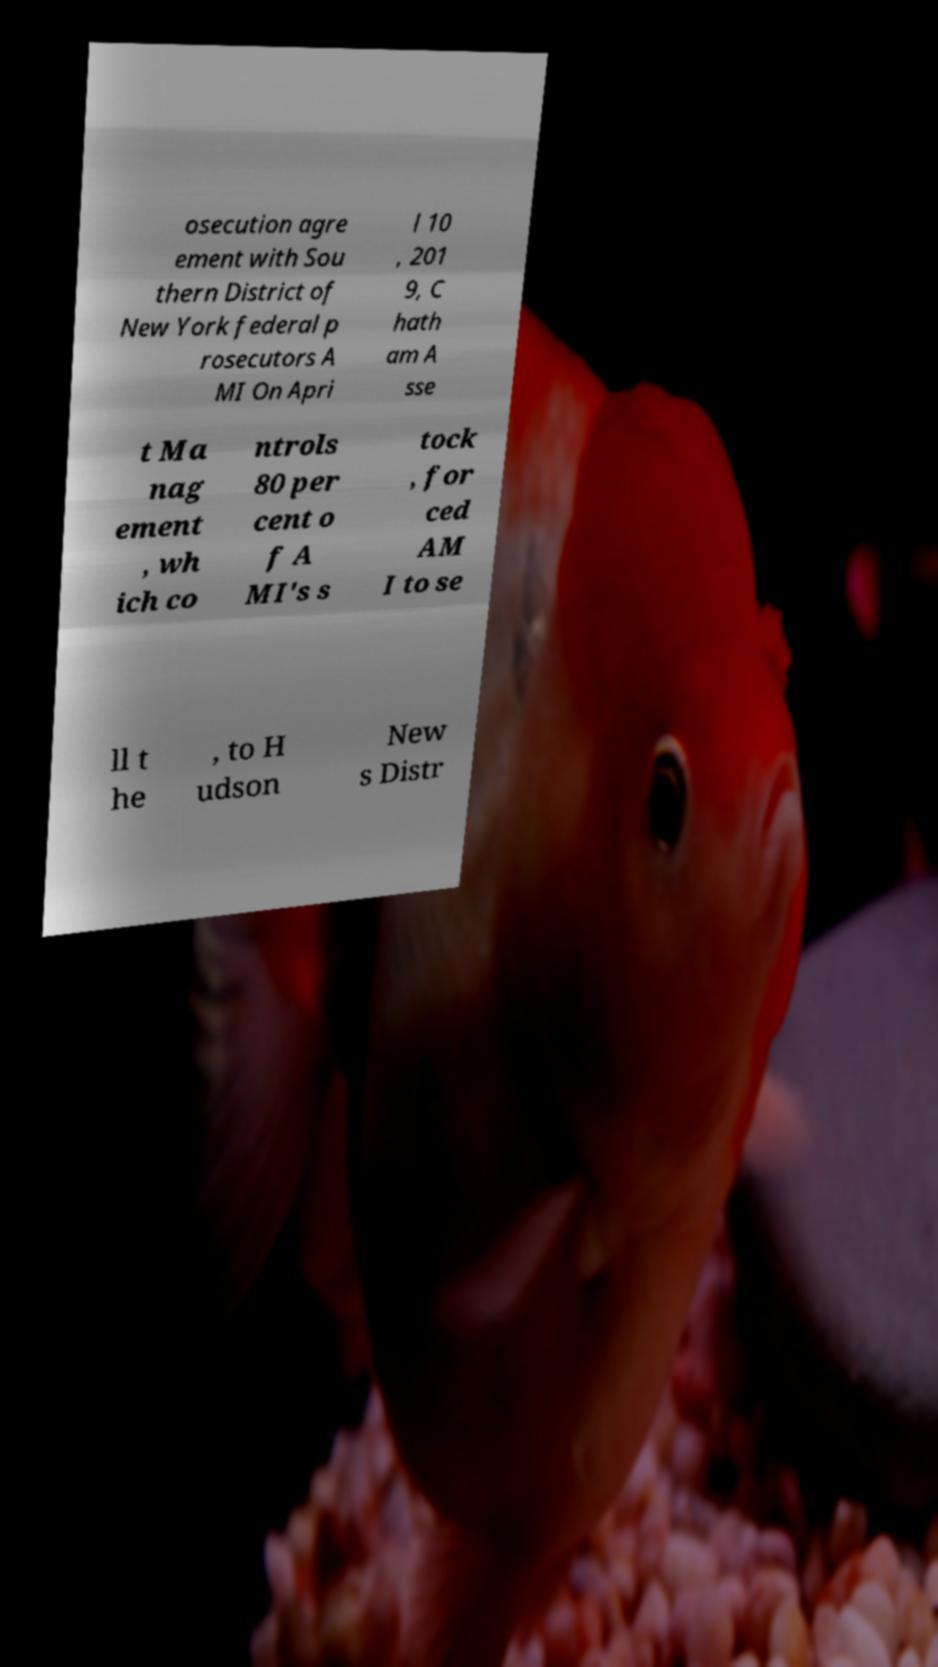Could you assist in decoding the text presented in this image and type it out clearly? osecution agre ement with Sou thern District of New York federal p rosecutors A MI On Apri l 10 , 201 9, C hath am A sse t Ma nag ement , wh ich co ntrols 80 per cent o f A MI's s tock , for ced AM I to se ll t he , to H udson New s Distr 